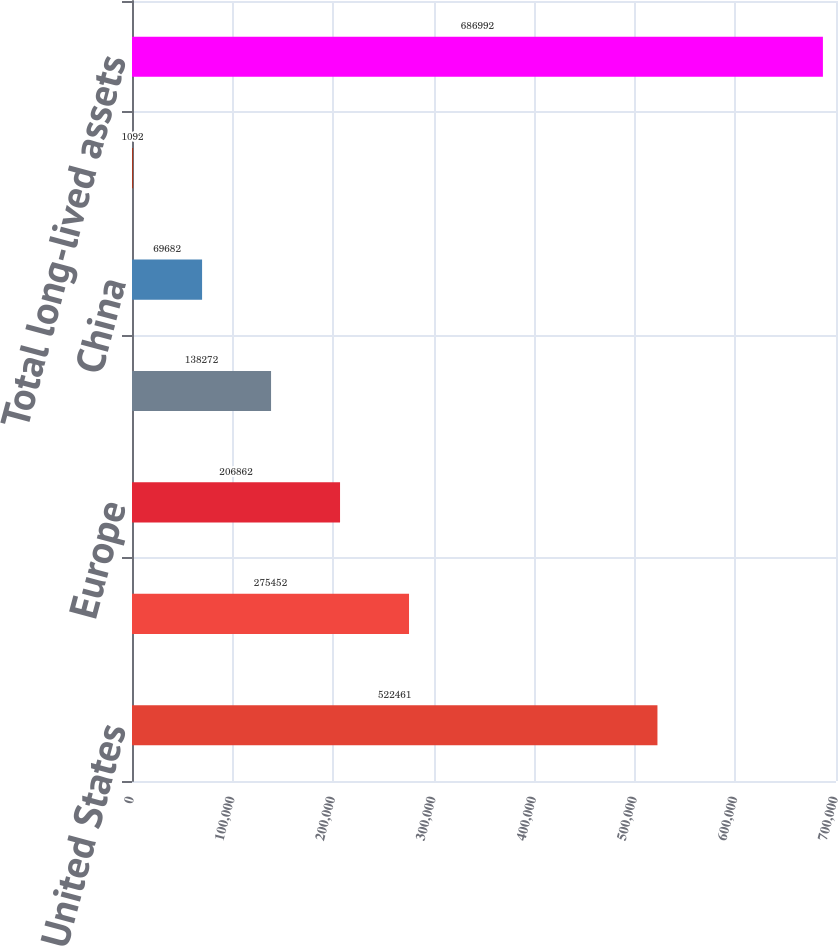Convert chart to OTSL. <chart><loc_0><loc_0><loc_500><loc_500><bar_chart><fcel>United States<fcel>Taiwan<fcel>Europe<fcel>India<fcel>China<fcel>Other Asia Pacific<fcel>Total long-lived assets<nl><fcel>522461<fcel>275452<fcel>206862<fcel>138272<fcel>69682<fcel>1092<fcel>686992<nl></chart> 